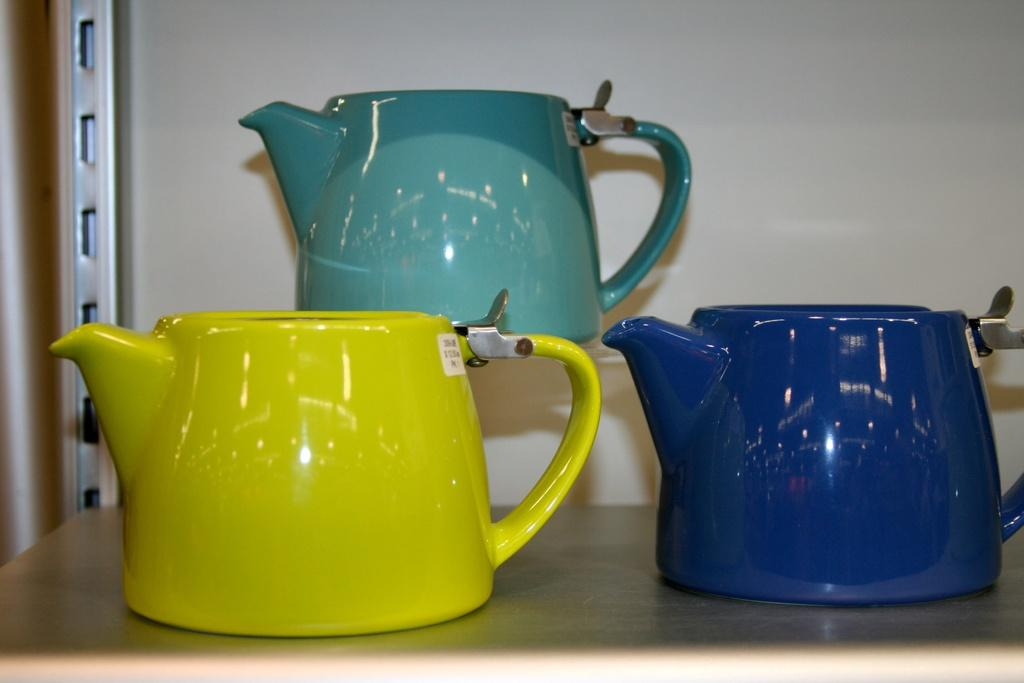How many kettles are visible in the image? There are three kettles in the image. How are the kettles arranged in the image? The kettles are arranged in a rack. What type of throat medicine is stored in the kettles in the image? There is no throat medicine or any reference to medicine in the image; it only features kettles arranged in a rack. 